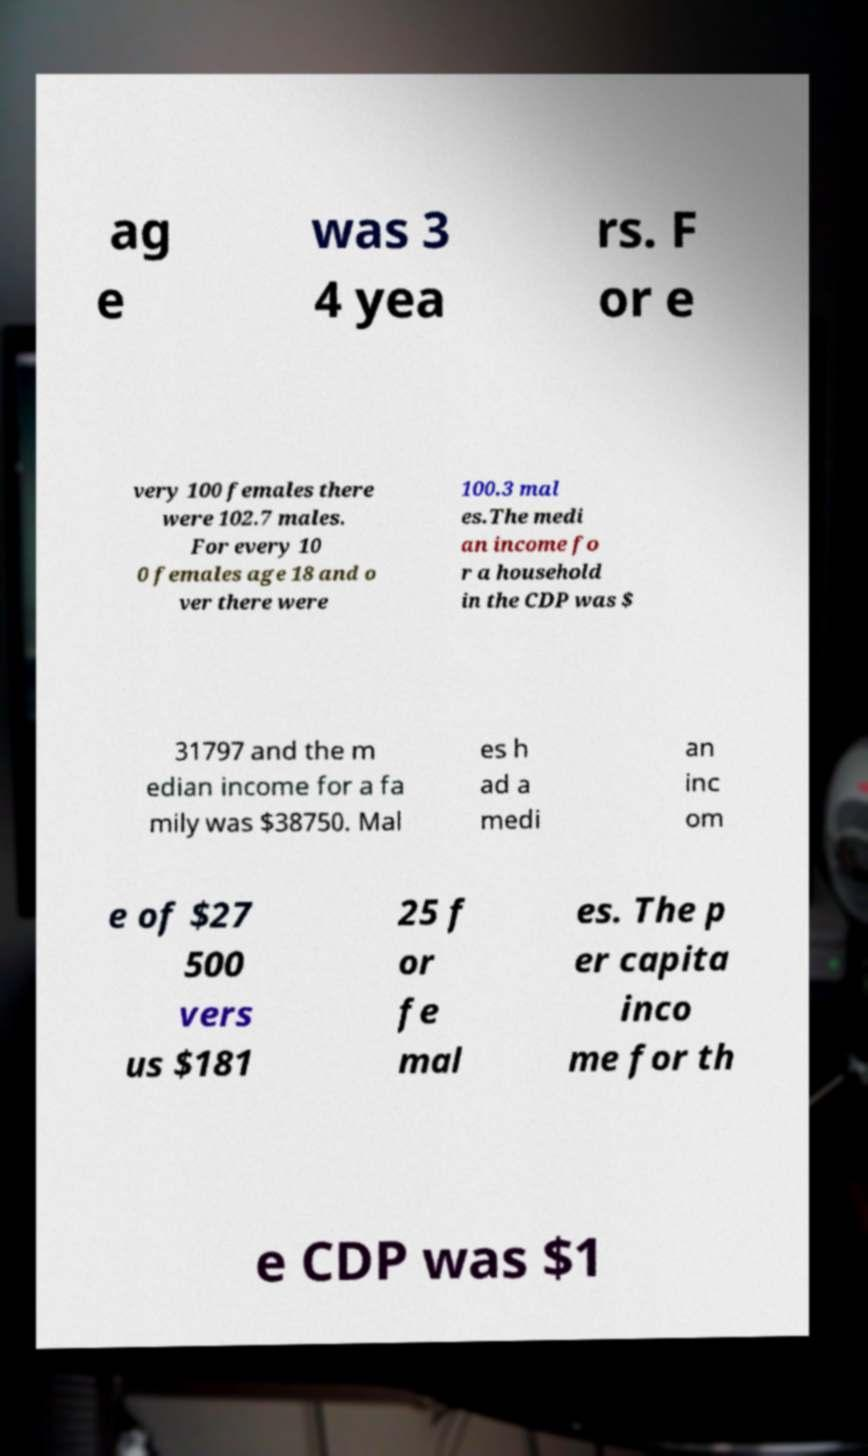Could you assist in decoding the text presented in this image and type it out clearly? ag e was 3 4 yea rs. F or e very 100 females there were 102.7 males. For every 10 0 females age 18 and o ver there were 100.3 mal es.The medi an income fo r a household in the CDP was $ 31797 and the m edian income for a fa mily was $38750. Mal es h ad a medi an inc om e of $27 500 vers us $181 25 f or fe mal es. The p er capita inco me for th e CDP was $1 